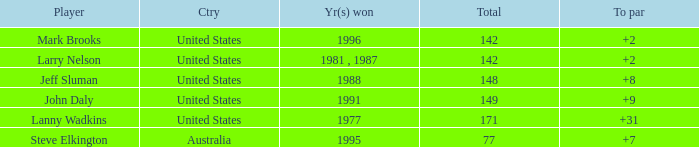Name the Total of australia and a To par smaller than 7? None. 